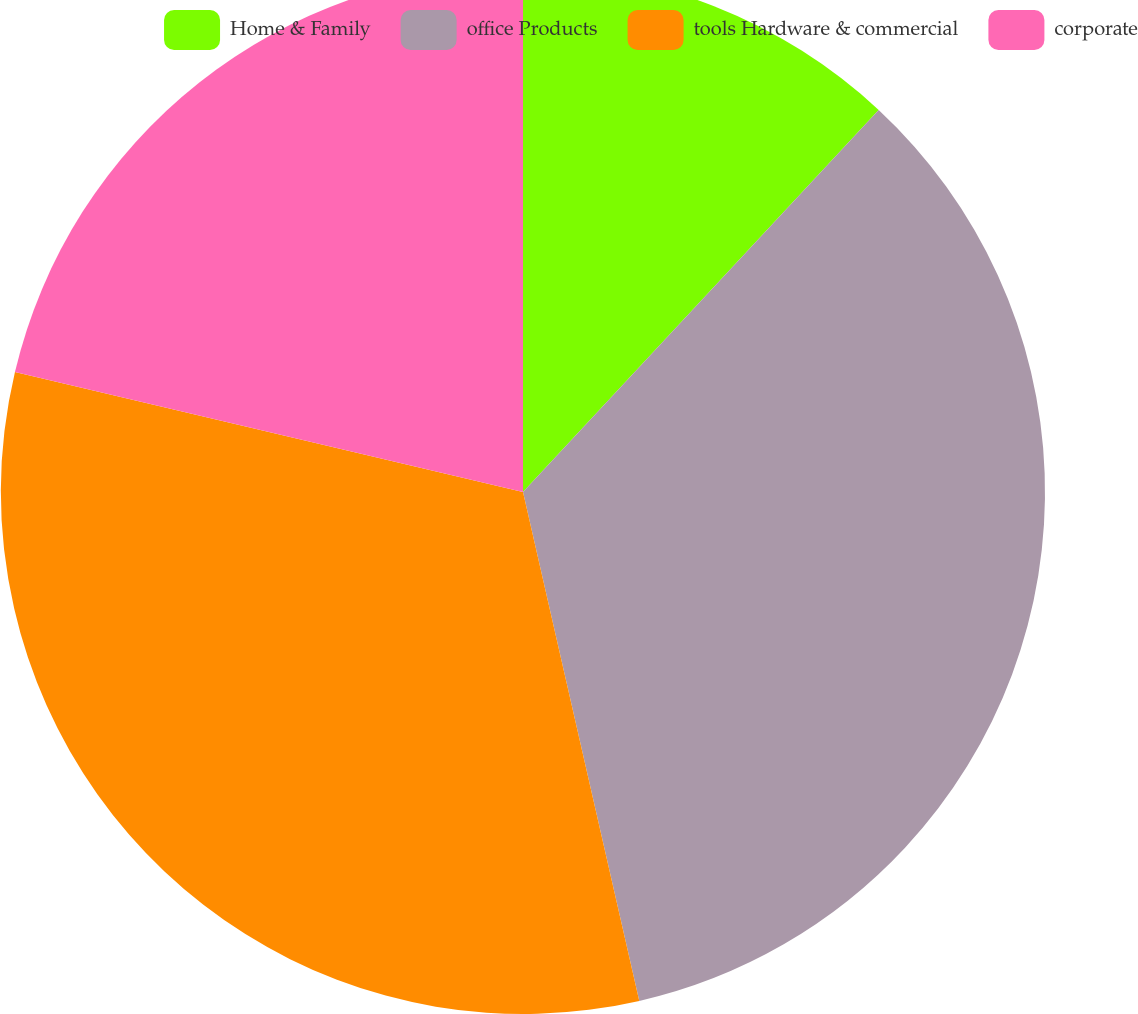Convert chart to OTSL. <chart><loc_0><loc_0><loc_500><loc_500><pie_chart><fcel>Home & Family<fcel>office Products<fcel>tools Hardware & commercial<fcel>corporate<nl><fcel>11.93%<fcel>34.49%<fcel>32.26%<fcel>21.31%<nl></chart> 